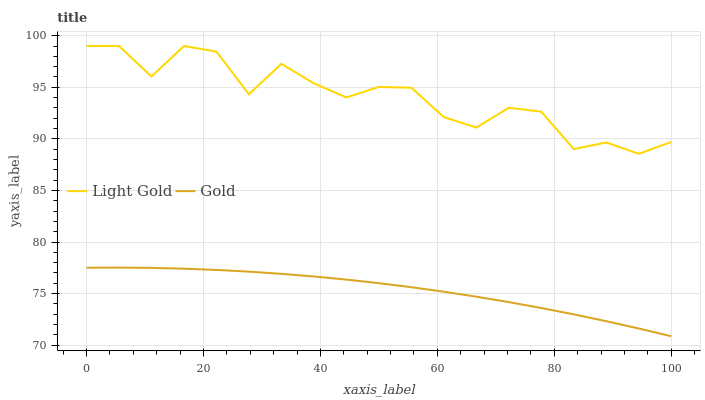Does Gold have the minimum area under the curve?
Answer yes or no. Yes. Does Light Gold have the maximum area under the curve?
Answer yes or no. Yes. Does Gold have the maximum area under the curve?
Answer yes or no. No. Is Gold the smoothest?
Answer yes or no. Yes. Is Light Gold the roughest?
Answer yes or no. Yes. Is Gold the roughest?
Answer yes or no. No. Does Light Gold have the highest value?
Answer yes or no. Yes. Does Gold have the highest value?
Answer yes or no. No. Is Gold less than Light Gold?
Answer yes or no. Yes. Is Light Gold greater than Gold?
Answer yes or no. Yes. Does Gold intersect Light Gold?
Answer yes or no. No. 